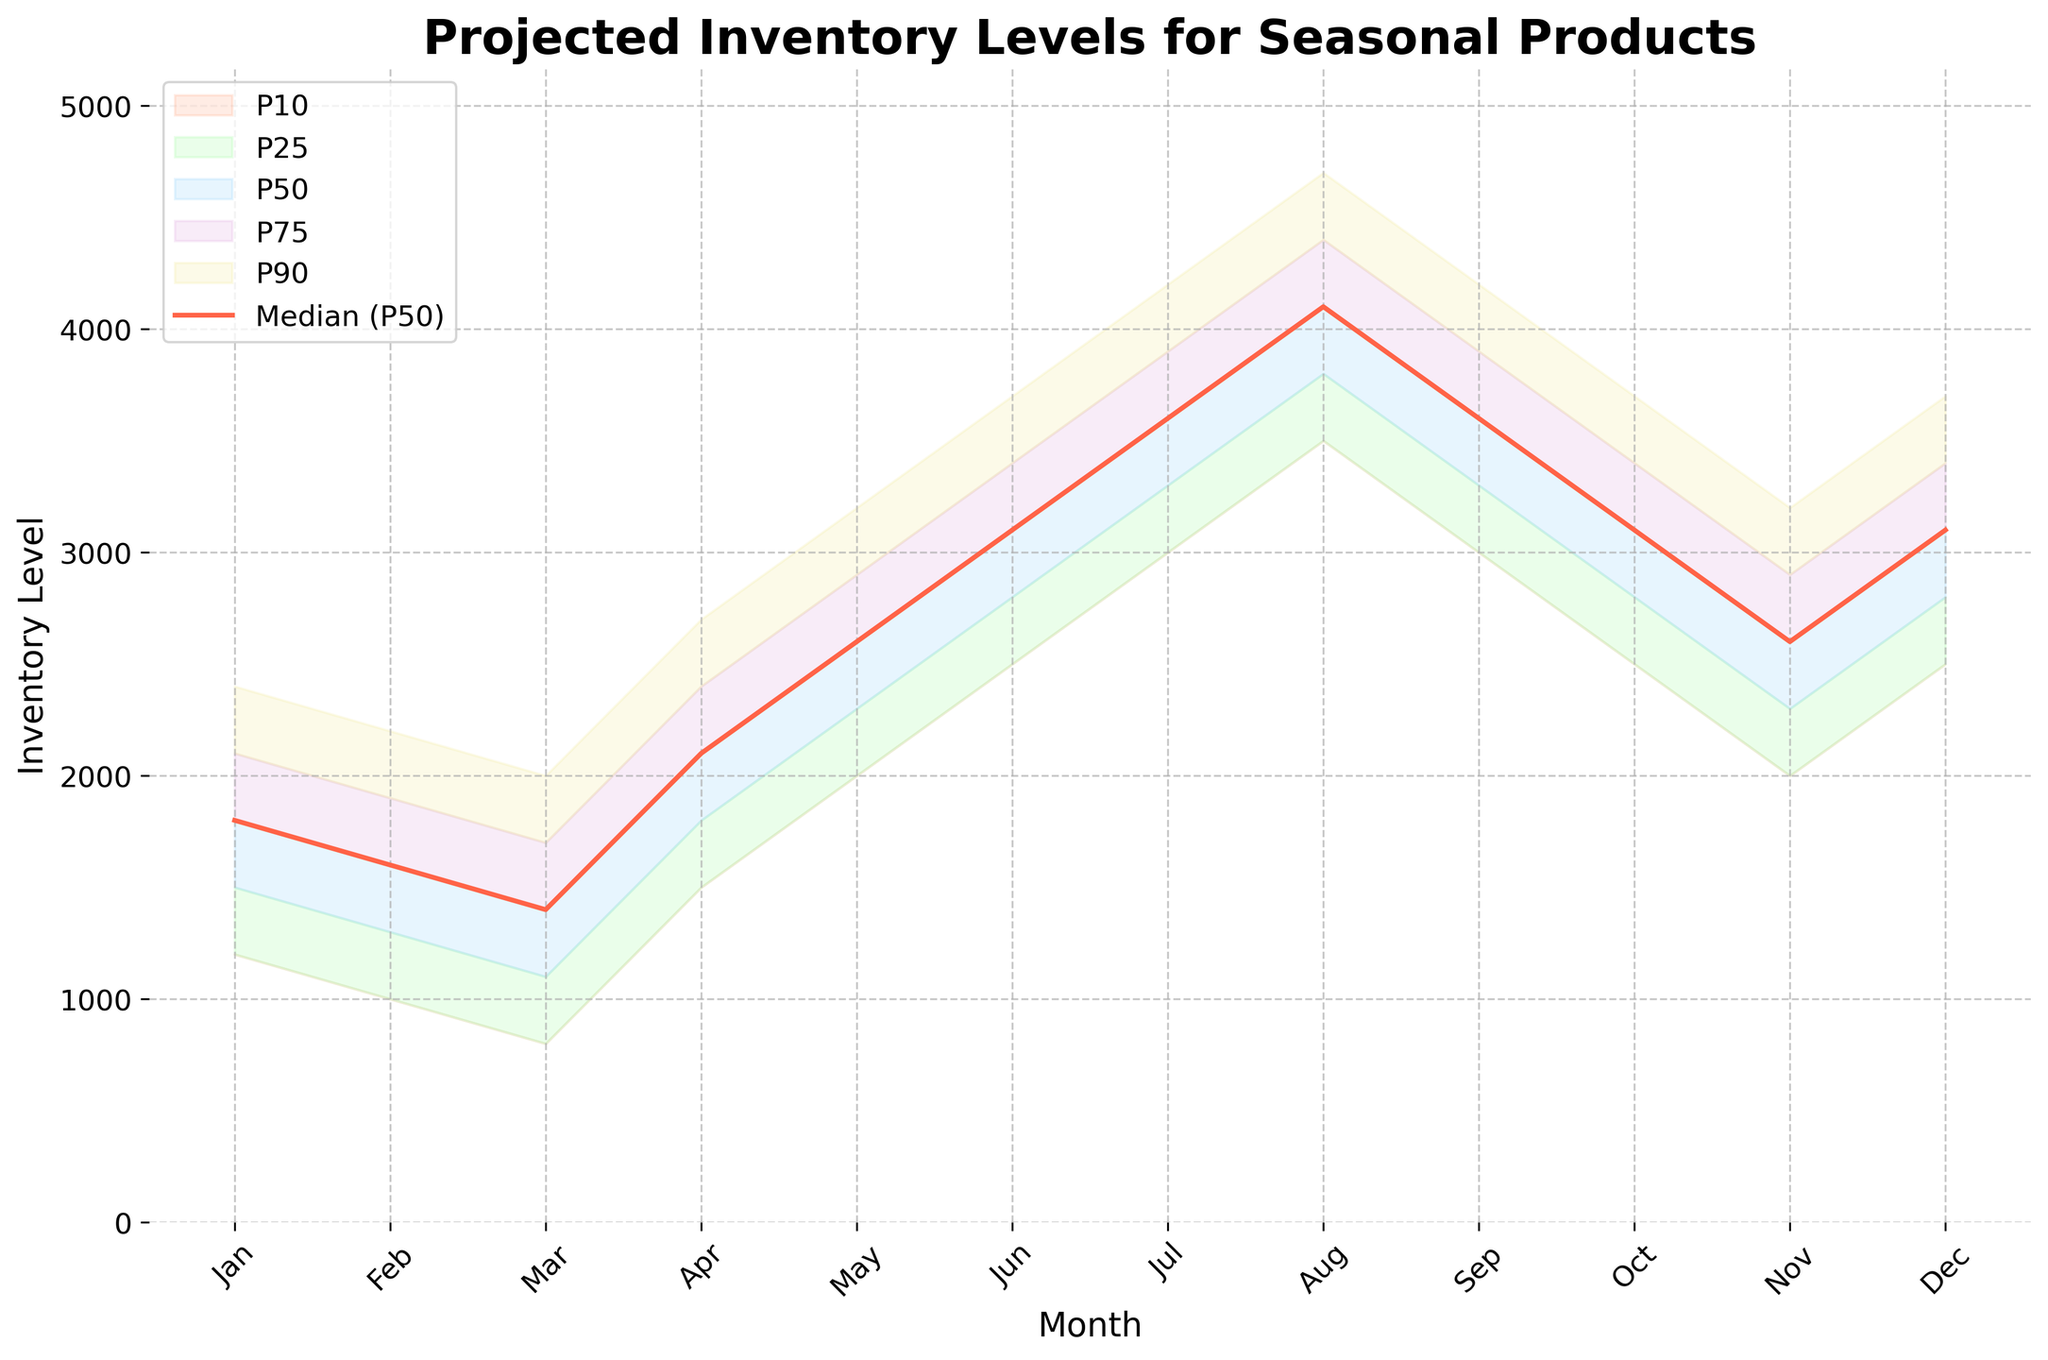When do the projected inventory levels peak for the median (P50) forecast? According to the plot, the projected inventory levels for the median forecast (P50) peak in August. The plot shows the highest value for the P50 line in August.
Answer: August What is the title of the plot? The title of the plot appears at the top of the figure and it reads "Projected Inventory Levels for Seasonal Products".
Answer: Projected Inventory Levels for Seasonal Products What is the range of the projected inventory levels in January at the 10th and 90th percentiles? In January, the inventory level at the 10th percentile is 1200 and at the 90th percentile, it is 2400. This range can be observed by looking at the respective points on the y-axis for these percentiles.
Answer: 1200 to 2400 How does the inventory level change from May to July for the P50 line? From the chart, the P50 line's inventory level in May is 2600, in June it is 3100, and in July it is 3600. So, the inventory level increases by 1000 from May to July.
Answer: Increases by 1000 Which month has the lowest projected inventory level at the 25th percentile? The month with the lowest projected inventory level at the 25th percentile is March, with a value of 1100, as observed from the plot.
Answer: March By how much does the upper bound of projection (P90) exceed the lower bound (P10) for November? For November, the P10 value is 2000 and the P90 value is 3200. The difference between these values is 3200 - 2000 = 1200.
Answer: Exceeds by 1200 For which months are the P50 inventory levels equal to 3100? The plot shows that the P50 inventory levels are equal to 3100 in June, October, and December, where the P50 line intersects the y-value of 3100.
Answer: June, October, December Compare the projected inventory levels at the 25th percentile for March and April. Which month has a higher value? According to the plot, the inventory levels at the 25th percentile for March and April are 1100 and 1800, respectively. Therefore, April has a higher value.
Answer: April What are the confidence intervals shown on the plot used for? The confidence intervals on the plot represent the range of projected inventory levels at different percentiles (P10, P25, P75, P90), which indicate the uncertainty and spread of the forecasts.
Answer: Represent the spread of forecasts How does the spread between the 10th and 90th percentiles change from January to August? The spread between the 10th and 90th percentiles in January is 1200 (2400 - 1200) and increases steadily, peaking in August with a spread of 1200 (4700 - 3500). The plot shows that the difference widens progressively till August.
Answer: Increases to 1200 